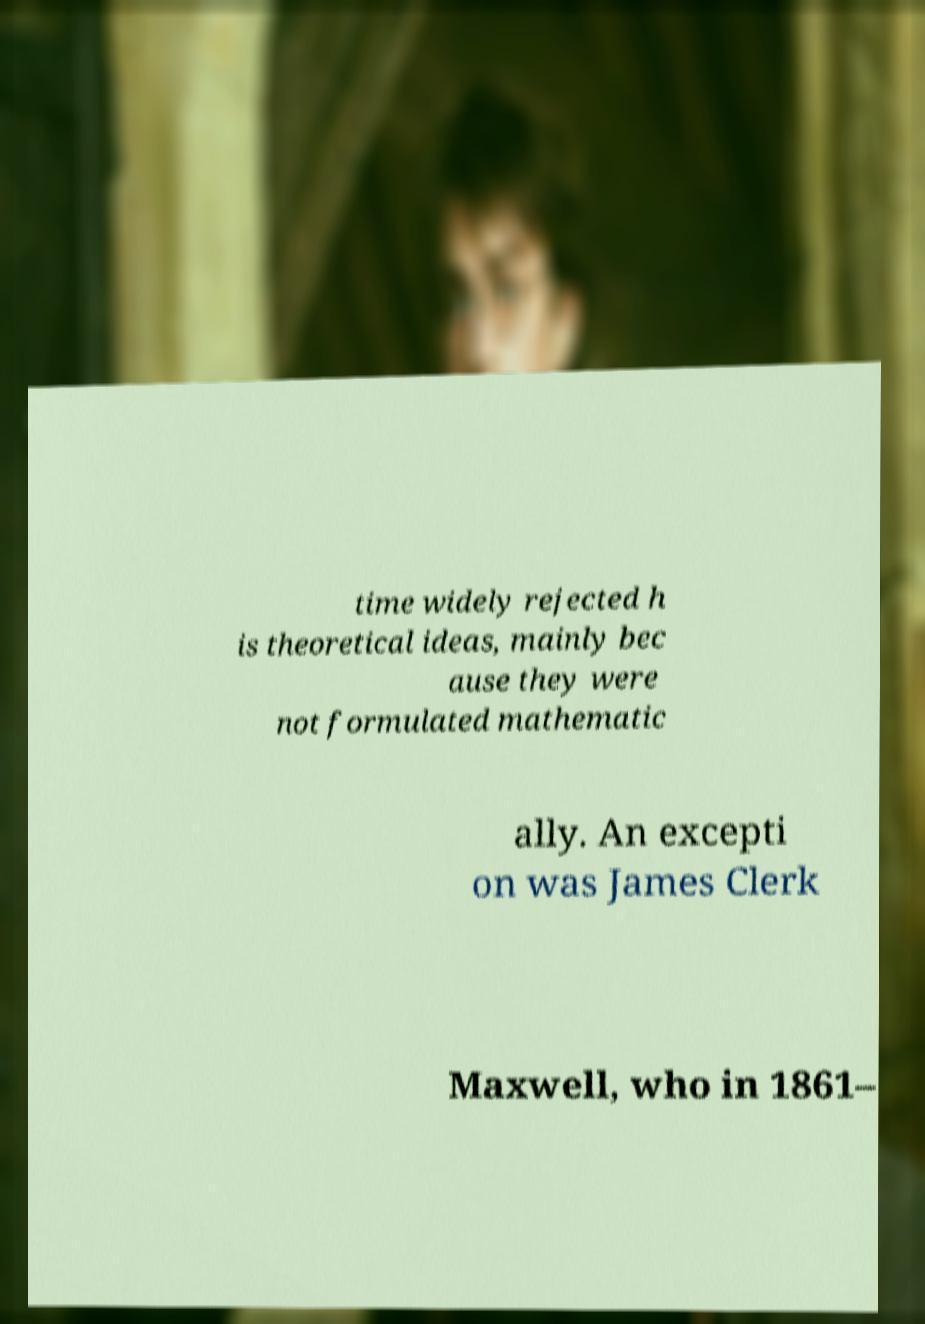There's text embedded in this image that I need extracted. Can you transcribe it verbatim? time widely rejected h is theoretical ideas, mainly bec ause they were not formulated mathematic ally. An excepti on was James Clerk Maxwell, who in 1861– 